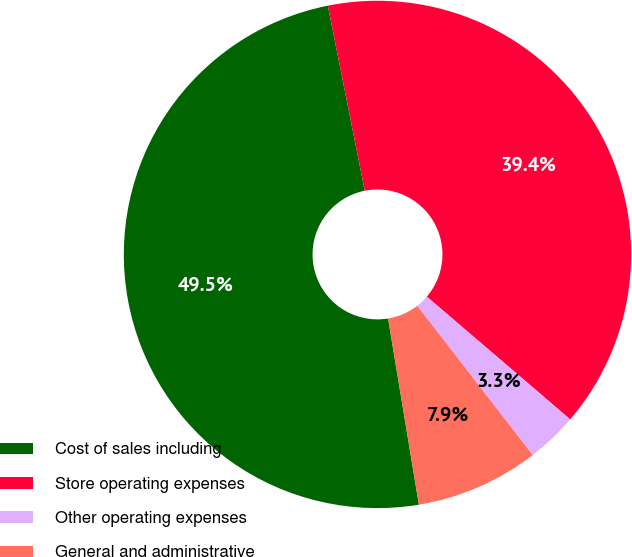<chart> <loc_0><loc_0><loc_500><loc_500><pie_chart><fcel>Cost of sales including<fcel>Store operating expenses<fcel>Other operating expenses<fcel>General and administrative<nl><fcel>49.47%<fcel>39.4%<fcel>3.25%<fcel>7.87%<nl></chart> 